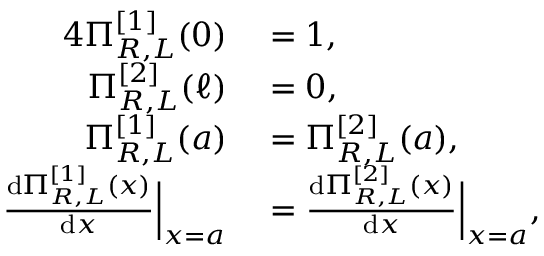<formula> <loc_0><loc_0><loc_500><loc_500>\begin{array} { r l } { { 4 } \Pi _ { R , L } ^ { [ 1 ] } ( 0 ) } & = 1 , } \\ { \Pi _ { R , L } ^ { [ 2 ] } ( \ell ) } & = 0 , } \\ { \Pi _ { R , L } ^ { [ 1 ] } ( a ) } & = \Pi _ { R , L } ^ { [ 2 ] } ( a ) , } \\ { \frac { d \Pi _ { R , L } ^ { [ 1 ] } ( x ) } { d x } \left | _ { x = a } } & = \frac { d \Pi _ { R , L } ^ { [ 2 ] } ( x ) } { d x } \right | _ { x = a } , } \end{array}</formula> 